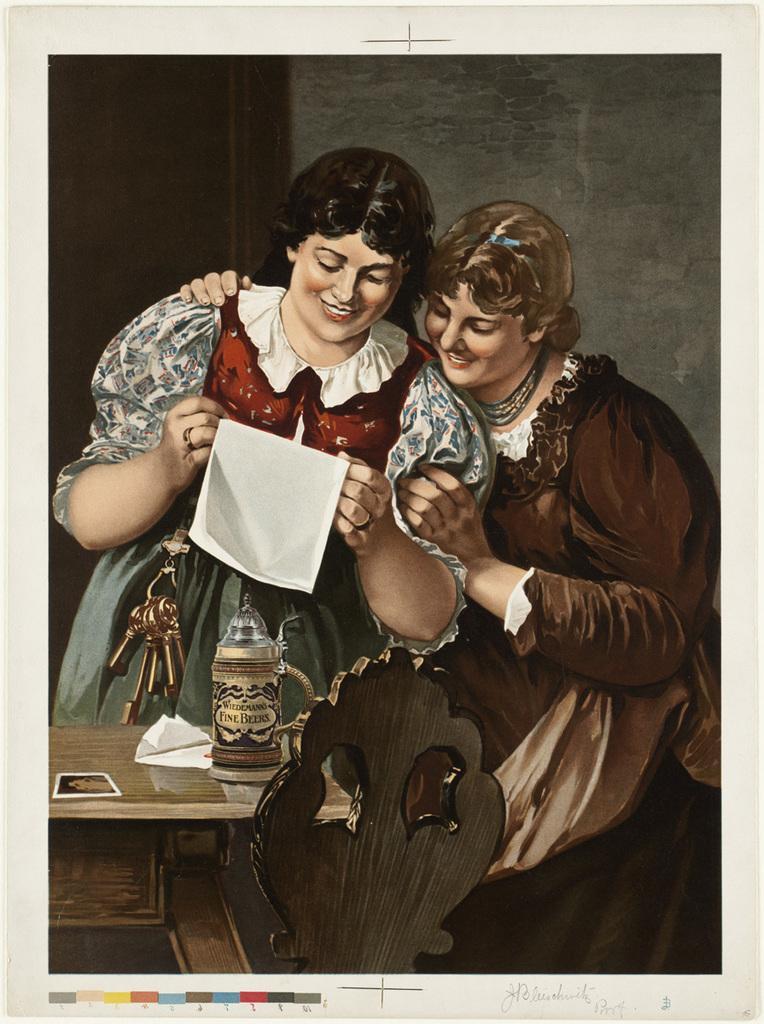How would you summarize this image in a sentence or two? This is a painting of an image. In the image there are two ladies standing. There is a lady holding a paper in the hand. And also there are a bunch of keys with her. In front of them there is a table with tissue, bottle and and object on it. And also there is a chair. In the background there is a wall with a door.  